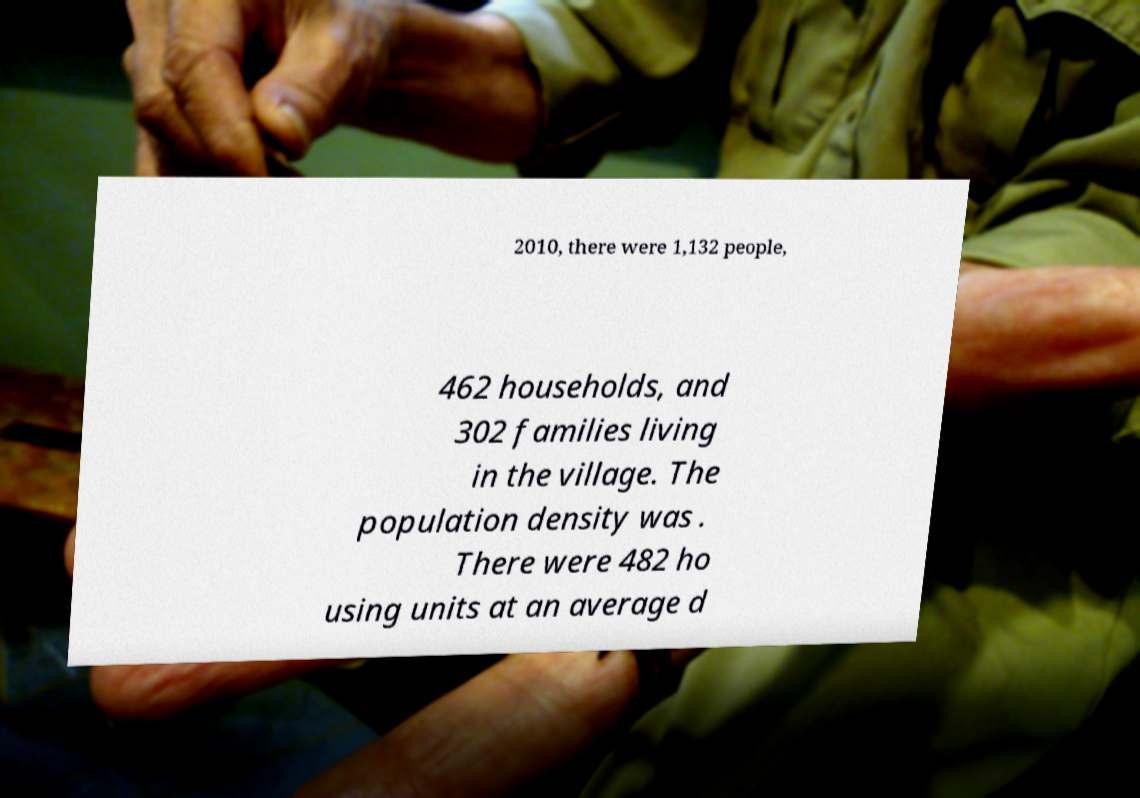Please read and relay the text visible in this image. What does it say? 2010, there were 1,132 people, 462 households, and 302 families living in the village. The population density was . There were 482 ho using units at an average d 